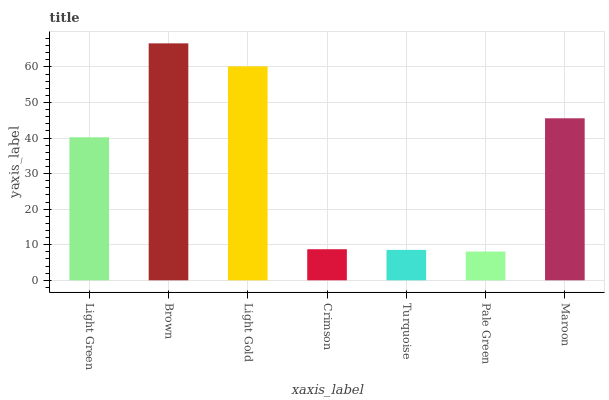Is Pale Green the minimum?
Answer yes or no. Yes. Is Brown the maximum?
Answer yes or no. Yes. Is Light Gold the minimum?
Answer yes or no. No. Is Light Gold the maximum?
Answer yes or no. No. Is Brown greater than Light Gold?
Answer yes or no. Yes. Is Light Gold less than Brown?
Answer yes or no. Yes. Is Light Gold greater than Brown?
Answer yes or no. No. Is Brown less than Light Gold?
Answer yes or no. No. Is Light Green the high median?
Answer yes or no. Yes. Is Light Green the low median?
Answer yes or no. Yes. Is Pale Green the high median?
Answer yes or no. No. Is Maroon the low median?
Answer yes or no. No. 